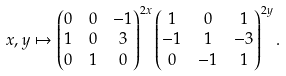<formula> <loc_0><loc_0><loc_500><loc_500>x , y & \mapsto \begin{pmatrix} 0 & 0 & - 1 \\ 1 & 0 & 3 \\ 0 & 1 & 0 \end{pmatrix} ^ { 2 x } \begin{pmatrix} 1 & 0 & 1 \\ - 1 & 1 & - 3 \\ 0 & - 1 & 1 \end{pmatrix} ^ { 2 y } .</formula> 